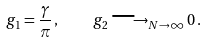<formula> <loc_0><loc_0><loc_500><loc_500>g _ { 1 } = \frac { \gamma } { \pi } \, , \quad g _ { 2 } \longrightarrow _ { N \to \infty } 0 \, .</formula> 